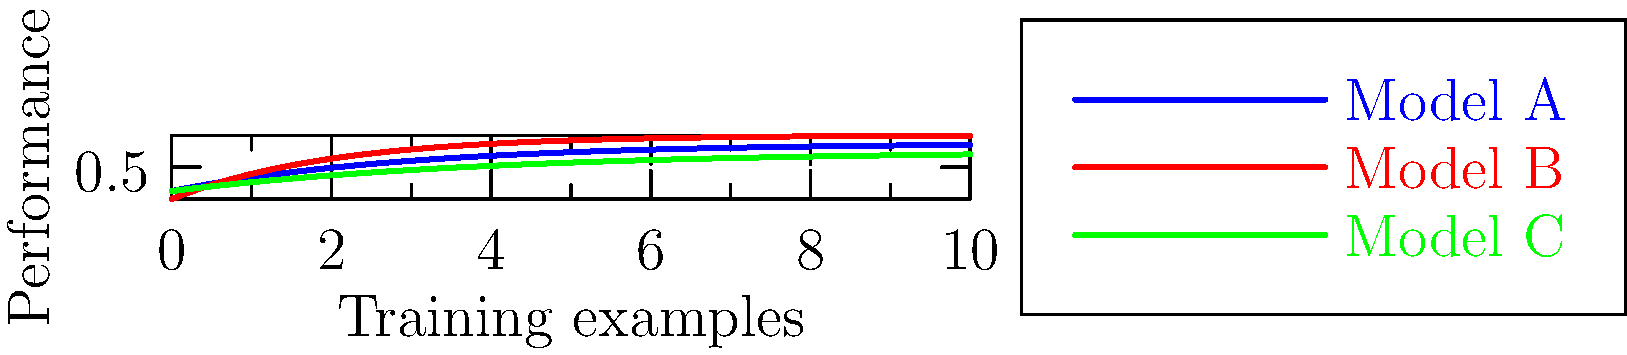Given the learning curves for three different model complexities (A, B, and C) shown in the graph, which model is most likely to be overfitting, and which one is most likely to be underfitting? Explain your reasoning in terms that would be understandable to a general audience. To answer this question, let's break down the concept of learning curves and model complexity for a general audience:

1. Learning curves show how a model's performance improves as it sees more training examples.

2. We look at two key aspects:
   a) The final performance level the model reaches
   b) How quickly the model reaches that level

3. Analyzing each model:
   - Model A (blue): Reaches a moderate performance level relatively quickly.
   - Model B (red): Achieves the highest performance but takes longer to reach it.
   - Model C (green): Has the lowest final performance and learns slowly.

4. Overfitting vs. Underfitting:
   - Overfitting occurs when a model is too complex and fits noise in the training data.
   - Underfitting happens when a model is too simple to capture the underlying patterns.

5. Identifying overfitting:
   - Model B shows signs of overfitting because it has the highest complexity.
   - It achieves the best performance but takes longer to learn, suggesting it might be capturing noise.

6. Identifying underfitting:
   - Model C shows clear signs of underfitting.
   - It has the lowest performance and learns slowly, indicating it's too simple to capture the data's complexity.

7. Model A appears to have a good balance, reaching a reasonable performance quickly without signs of over or underfitting.

In simple terms for a general audience:
- Model B (red) is like memorizing every detail in a textbook, even typos. It might do well on a specific test but struggle with new, slightly different problems.
- Model C (green) is like only learning chapter titles. It's too simple and misses important details.
- Model A (blue) is like learning the key concepts and some details – a good balance for general understanding and application.
Answer: Model B is likely overfitting; Model C is likely underfitting. 